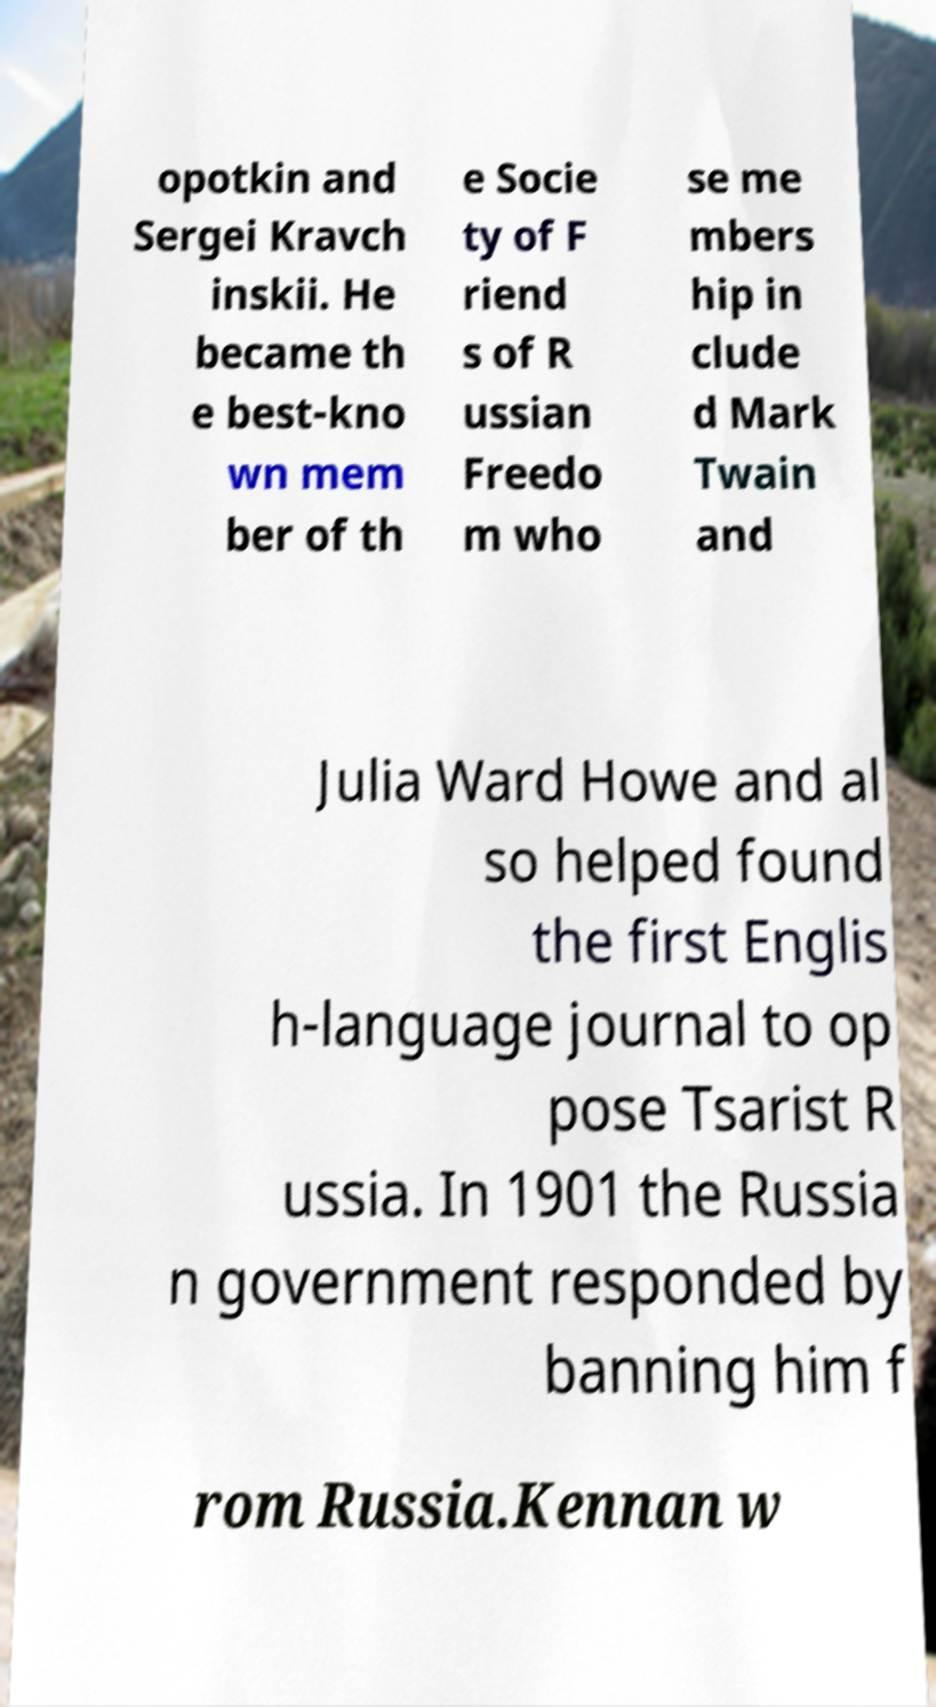Please read and relay the text visible in this image. What does it say? opotkin and Sergei Kravch inskii. He became th e best-kno wn mem ber of th e Socie ty of F riend s of R ussian Freedo m who se me mbers hip in clude d Mark Twain and Julia Ward Howe and al so helped found the first Englis h-language journal to op pose Tsarist R ussia. In 1901 the Russia n government responded by banning him f rom Russia.Kennan w 